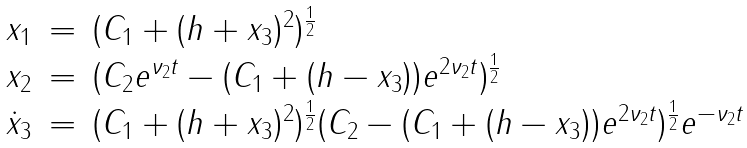Convert formula to latex. <formula><loc_0><loc_0><loc_500><loc_500>\begin{array} { l l l } x _ { 1 } & = & ( C _ { 1 } + ( h + x _ { 3 } ) ^ { 2 } ) ^ { \frac { 1 } { 2 } } \\ x _ { 2 } & = & ( C _ { 2 } e ^ { \nu _ { 2 } t } - ( C _ { 1 } + ( h - x _ { 3 } ) ) e ^ { 2 \nu _ { 2 } t } ) ^ { \frac { 1 } { 2 } } \\ \dot { x } _ { 3 } & = & ( C _ { 1 } + ( h + x _ { 3 } ) ^ { 2 } ) ^ { \frac { 1 } { 2 } } ( C _ { 2 } - ( C _ { 1 } + ( h - x _ { 3 } ) ) e ^ { 2 \nu _ { 2 } t } ) ^ { \frac { 1 } { 2 } } e ^ { - \nu _ { 2 } t } \\ \end{array}</formula> 